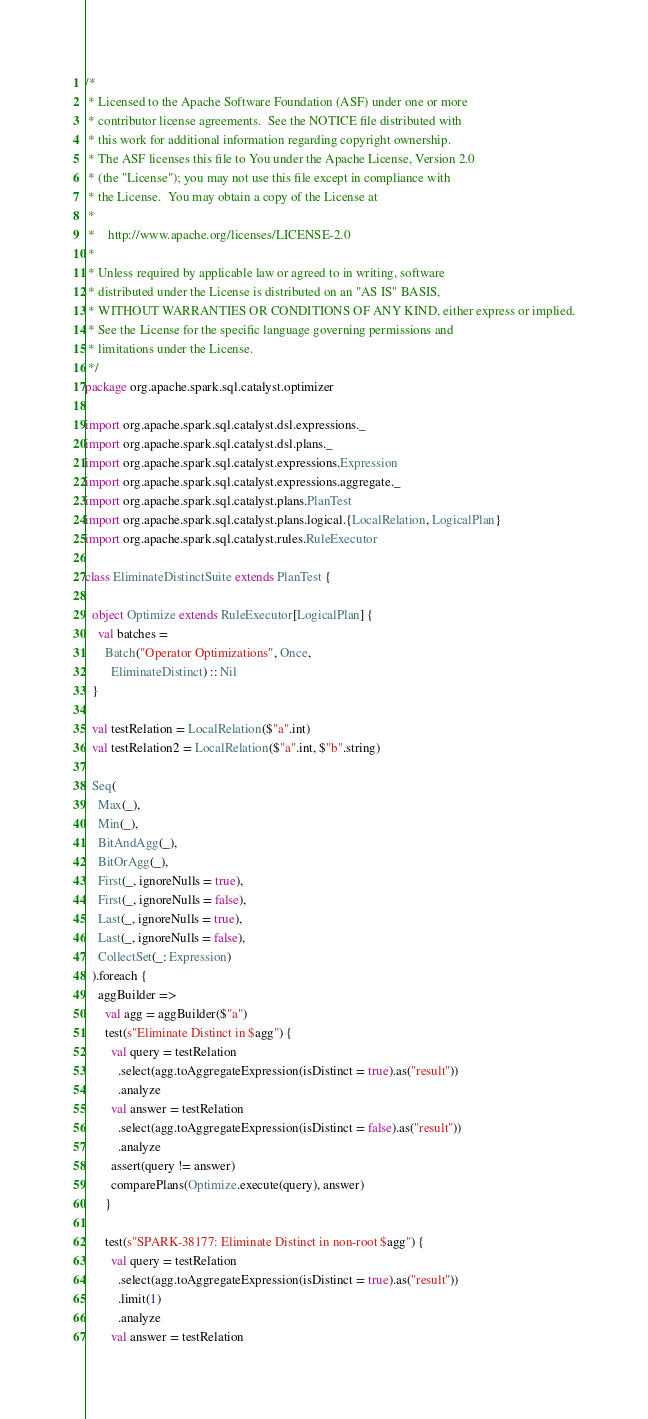<code> <loc_0><loc_0><loc_500><loc_500><_Scala_>/*
 * Licensed to the Apache Software Foundation (ASF) under one or more
 * contributor license agreements.  See the NOTICE file distributed with
 * this work for additional information regarding copyright ownership.
 * The ASF licenses this file to You under the Apache License, Version 2.0
 * (the "License"); you may not use this file except in compliance with
 * the License.  You may obtain a copy of the License at
 *
 *    http://www.apache.org/licenses/LICENSE-2.0
 *
 * Unless required by applicable law or agreed to in writing, software
 * distributed under the License is distributed on an "AS IS" BASIS,
 * WITHOUT WARRANTIES OR CONDITIONS OF ANY KIND, either express or implied.
 * See the License for the specific language governing permissions and
 * limitations under the License.
 */
package org.apache.spark.sql.catalyst.optimizer

import org.apache.spark.sql.catalyst.dsl.expressions._
import org.apache.spark.sql.catalyst.dsl.plans._
import org.apache.spark.sql.catalyst.expressions.Expression
import org.apache.spark.sql.catalyst.expressions.aggregate._
import org.apache.spark.sql.catalyst.plans.PlanTest
import org.apache.spark.sql.catalyst.plans.logical.{LocalRelation, LogicalPlan}
import org.apache.spark.sql.catalyst.rules.RuleExecutor

class EliminateDistinctSuite extends PlanTest {

  object Optimize extends RuleExecutor[LogicalPlan] {
    val batches =
      Batch("Operator Optimizations", Once,
        EliminateDistinct) :: Nil
  }

  val testRelation = LocalRelation($"a".int)
  val testRelation2 = LocalRelation($"a".int, $"b".string)

  Seq(
    Max(_),
    Min(_),
    BitAndAgg(_),
    BitOrAgg(_),
    First(_, ignoreNulls = true),
    First(_, ignoreNulls = false),
    Last(_, ignoreNulls = true),
    Last(_, ignoreNulls = false),
    CollectSet(_: Expression)
  ).foreach {
    aggBuilder =>
      val agg = aggBuilder($"a")
      test(s"Eliminate Distinct in $agg") {
        val query = testRelation
          .select(agg.toAggregateExpression(isDistinct = true).as("result"))
          .analyze
        val answer = testRelation
          .select(agg.toAggregateExpression(isDistinct = false).as("result"))
          .analyze
        assert(query != answer)
        comparePlans(Optimize.execute(query), answer)
      }

      test(s"SPARK-38177: Eliminate Distinct in non-root $agg") {
        val query = testRelation
          .select(agg.toAggregateExpression(isDistinct = true).as("result"))
          .limit(1)
          .analyze
        val answer = testRelation</code> 